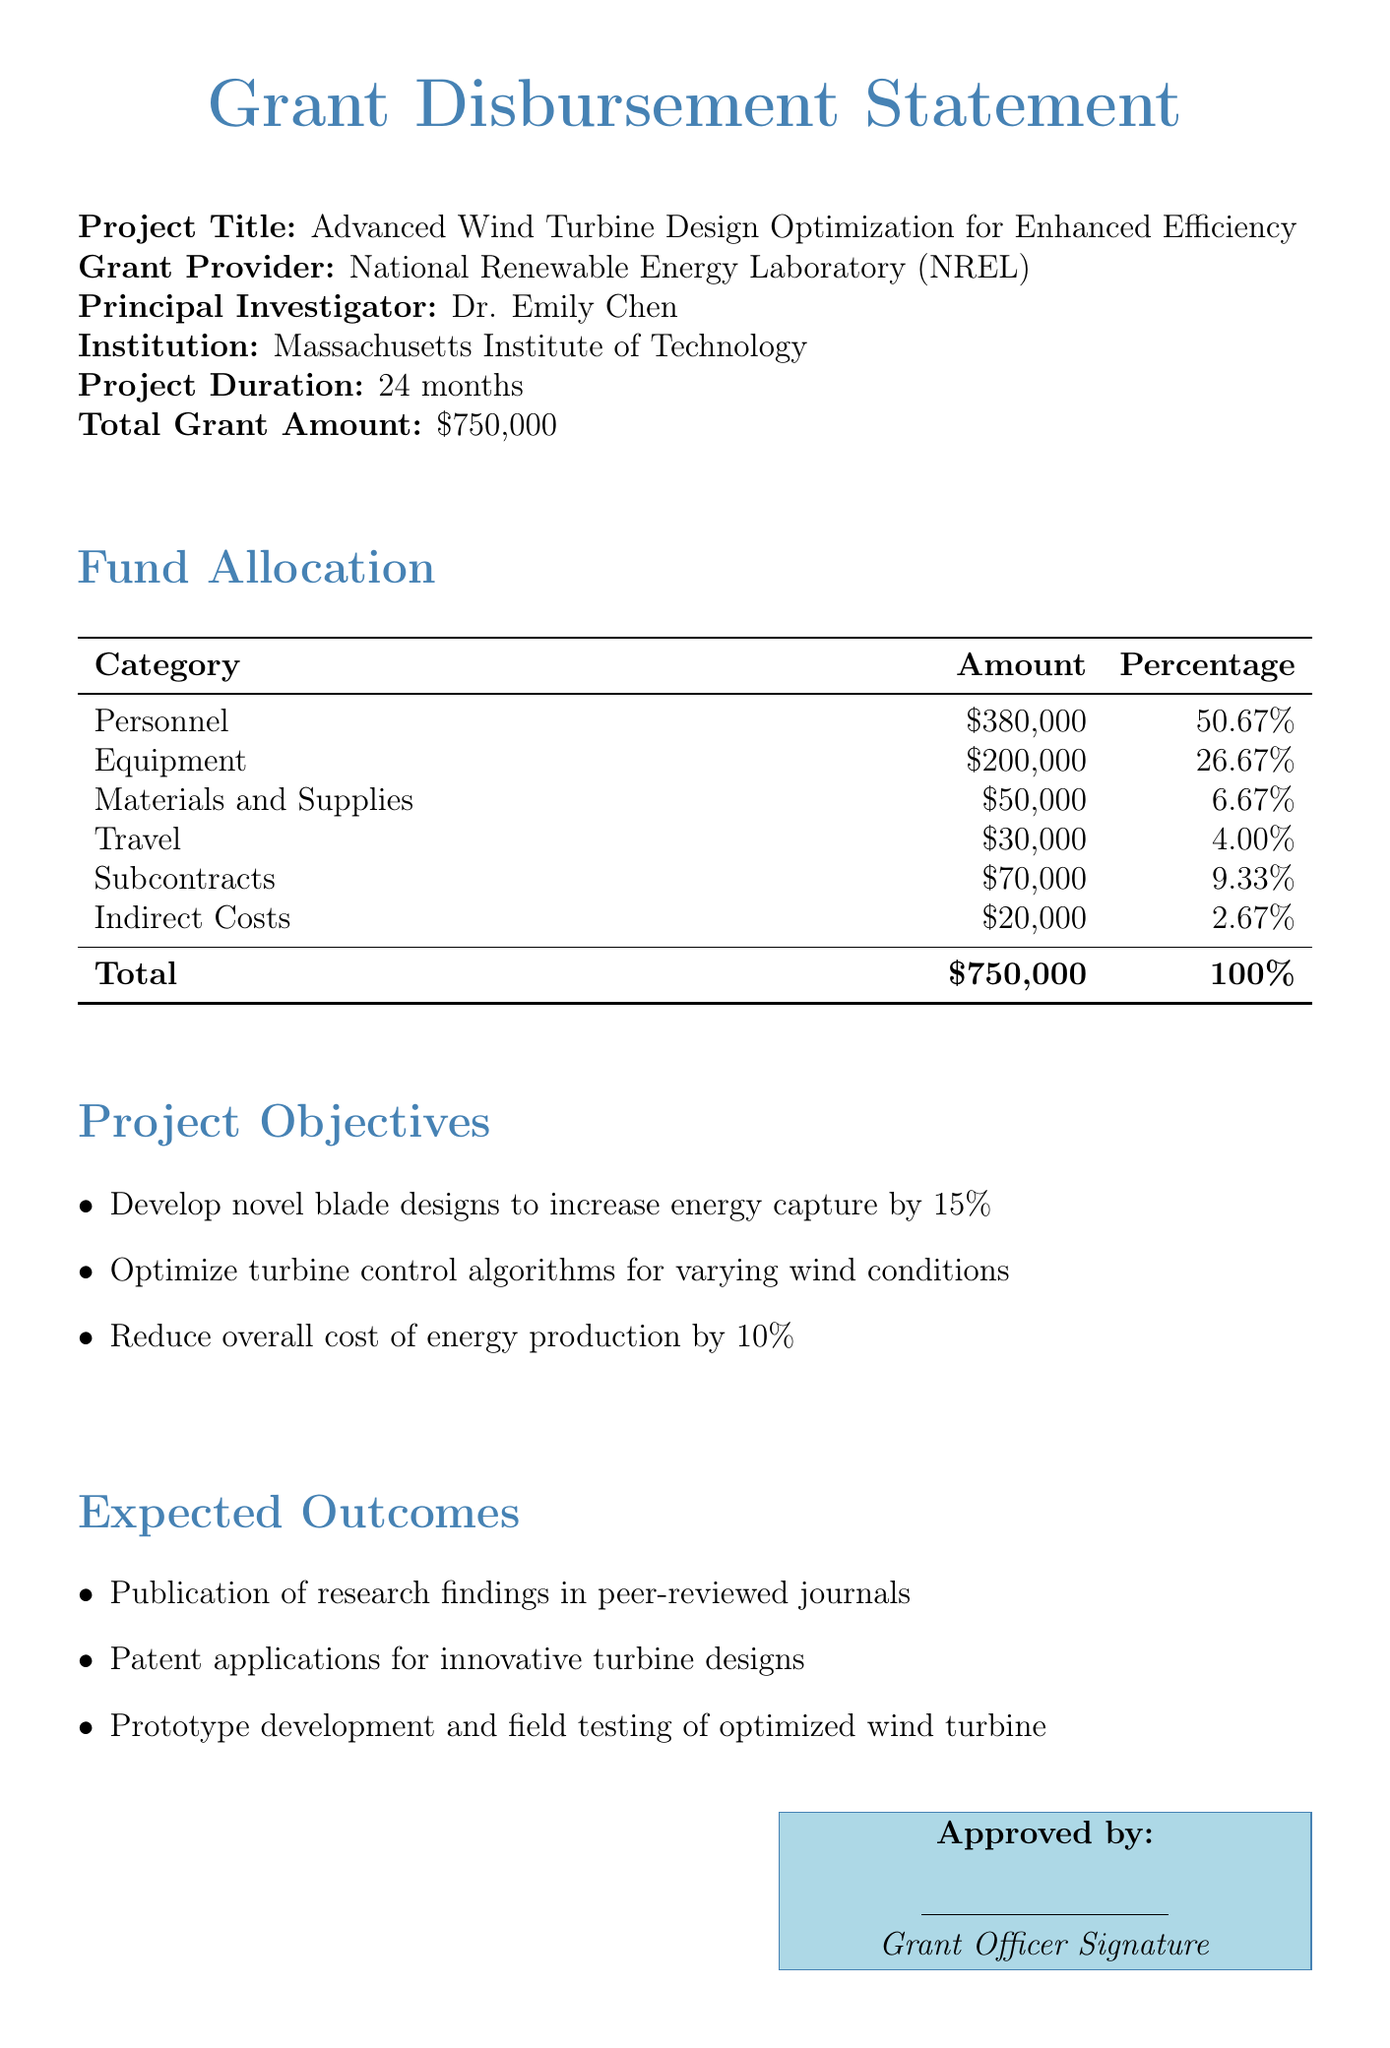What is the project title? The project title is listed at the beginning of the document under the section for project details.
Answer: Advanced Wind Turbine Design Optimization for Enhanced Efficiency Who is the Principal Investigator? The Principal Investigator is mentioned in the project details section.
Answer: Dr. Emily Chen What is the total grant amount? The total grant amount is specified in the project details section.
Answer: $750,000 What percentage of the grant is allocated to personnel? The percentage allocated to personnel is listed in the fund allocation table.
Answer: 50.67% How much funding is allocated for equipment? The amount allocated for equipment is detailed in the fund allocation section.
Answer: $200,000 What is the duration of the project? The duration of the project is stated in the project details section.
Answer: 24 months What is one of the project objectives? The project objectives are listed in a bullet-point format in the document.
Answer: Develop novel blade designs to increase energy capture by 15% What is the total percentage of indirect costs? The total percentage for indirect costs is specified in the fund allocation table.
Answer: 2.67% What is expected as an outcome of the project? Expected outcomes are listed in a bullet-point format in the document.
Answer: Publication of research findings in peer-reviewed journals What is the name of the grant provider? The grant provider is mentioned in the project details section.
Answer: National Renewable Energy Laboratory (NREL) 